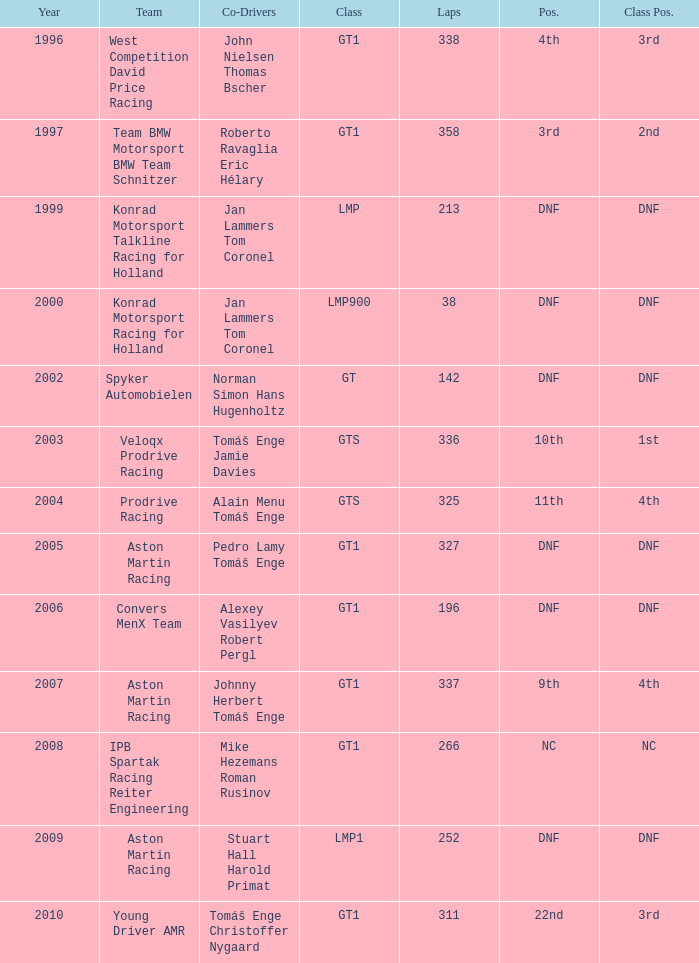In which division had 252 laps and a rank of dnf? LMP1. 